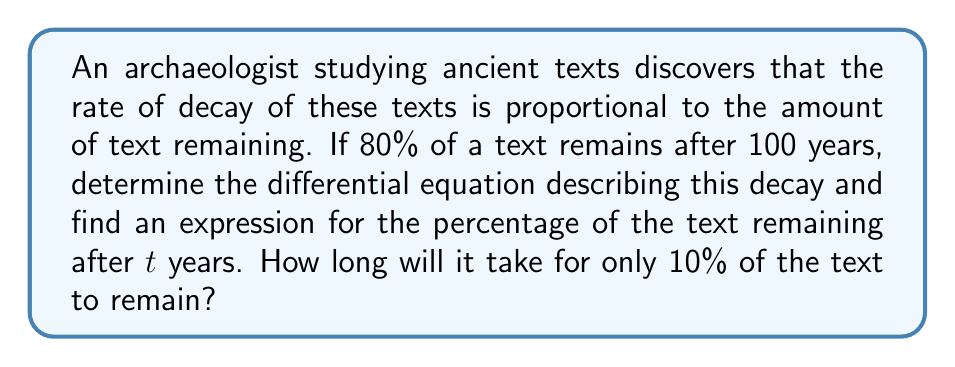Help me with this question. Let's approach this problem step-by-step:

1) Let $P(t)$ represent the percentage of the text remaining at time $t$ (in years).

2) The rate of decay is proportional to the amount remaining. This can be expressed as:

   $$\frac{dP}{dt} = -kP$$

   where $k$ is the decay constant.

3) To solve this differential equation, we can separate variables:

   $$\frac{dP}{P} = -k dt$$

4) Integrating both sides:

   $$\int \frac{dP}{P} = -k \int dt$$
   $$\ln|P| = -kt + C$$

5) Taking the exponential of both sides:

   $$P = e^{-kt + C} = Ae^{-kt}$$

   where $A = e^C$ is a constant.

6) We know that at $t = 0$, 100% of the text remains. So $P(0) = 100$:

   $$100 = Ae^{-k(0)} = A$$

7) Therefore, our general solution is:

   $$P(t) = 100e^{-kt}$$

8) We're told that 80% remains after 100 years. Let's use this to find $k$:

   $$80 = 100e^{-k(100)}$$
   $$0.8 = e^{-100k}$$
   $$\ln(0.8) = -100k$$
   $$k = -\frac{\ln(0.8)}{100} \approx 0.002231$$

9) Now we have our complete equation:

   $$P(t) = 100e^{-0.002231t}$$

10) To find when 10% remains, we solve:

    $$10 = 100e^{-0.002231t}$$
    $$0.1 = e^{-0.002231t}$$
    $$\ln(0.1) = -0.002231t$$
    $$t = \frac{\ln(0.1)}{-0.002231} \approx 1031.5$$

Thus, it will take approximately 1031.5 years for only 10% of the text to remain.
Answer: The differential equation describing the decay is $\frac{dP}{dt} = -kP$ where $k \approx 0.002231$. The expression for the percentage of text remaining after $t$ years is $P(t) = 100e^{-0.002231t}$. It will take approximately 1031.5 years for only 10% of the text to remain. 